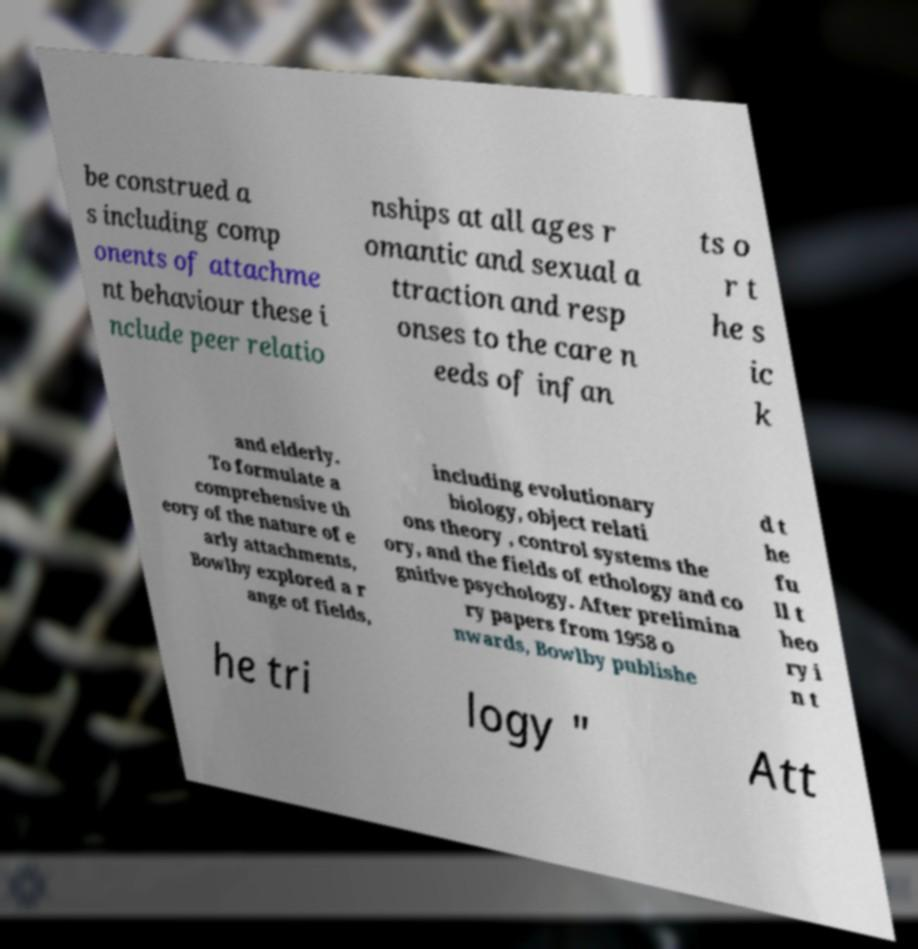What messages or text are displayed in this image? I need them in a readable, typed format. be construed a s including comp onents of attachme nt behaviour these i nclude peer relatio nships at all ages r omantic and sexual a ttraction and resp onses to the care n eeds of infan ts o r t he s ic k and elderly. To formulate a comprehensive th eory of the nature of e arly attachments, Bowlby explored a r ange of fields, including evolutionary biology, object relati ons theory , control systems the ory, and the fields of ethology and co gnitive psychology. After prelimina ry papers from 1958 o nwards, Bowlby publishe d t he fu ll t heo ry i n t he tri logy " Att 